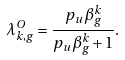Convert formula to latex. <formula><loc_0><loc_0><loc_500><loc_500>\lambda _ { k , g } ^ { O } = \frac { p _ { u } \beta _ { g } ^ { k } } { p _ { u } \beta _ { g } ^ { k } + 1 } .</formula> 